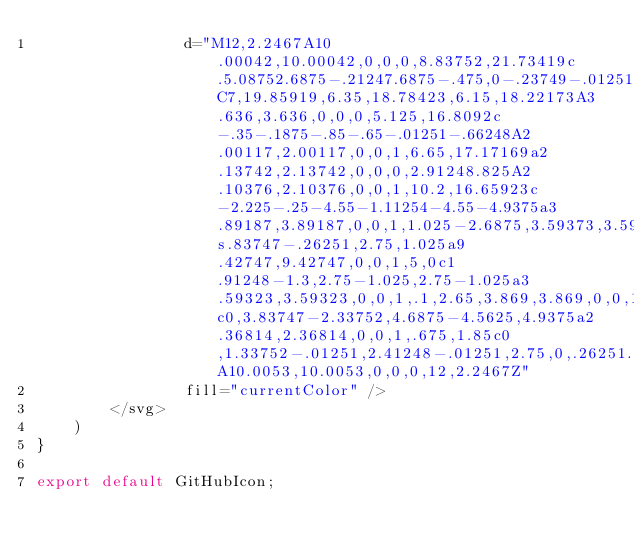Convert code to text. <code><loc_0><loc_0><loc_500><loc_500><_JavaScript_>                d="M12,2.2467A10.00042,10.00042,0,0,0,8.83752,21.73419c.5.08752.6875-.21247.6875-.475,0-.23749-.01251-1.025-.01251-1.86249C7,19.85919,6.35,18.78423,6.15,18.22173A3.636,3.636,0,0,0,5.125,16.8092c-.35-.1875-.85-.65-.01251-.66248A2.00117,2.00117,0,0,1,6.65,17.17169a2.13742,2.13742,0,0,0,2.91248.825A2.10376,2.10376,0,0,1,10.2,16.65923c-2.225-.25-4.55-1.11254-4.55-4.9375a3.89187,3.89187,0,0,1,1.025-2.6875,3.59373,3.59373,0,0,1,.1-2.65s.83747-.26251,2.75,1.025a9.42747,9.42747,0,0,1,5,0c1.91248-1.3,2.75-1.025,2.75-1.025a3.59323,3.59323,0,0,1,.1,2.65,3.869,3.869,0,0,1,1.025,2.6875c0,3.83747-2.33752,4.6875-4.5625,4.9375a2.36814,2.36814,0,0,1,.675,1.85c0,1.33752-.01251,2.41248-.01251,2.75,0,.26251.1875.575.6875.475A10.0053,10.0053,0,0,0,12,2.2467Z"
                fill="currentColor" />
        </svg>
    )
}

export default GitHubIcon;</code> 